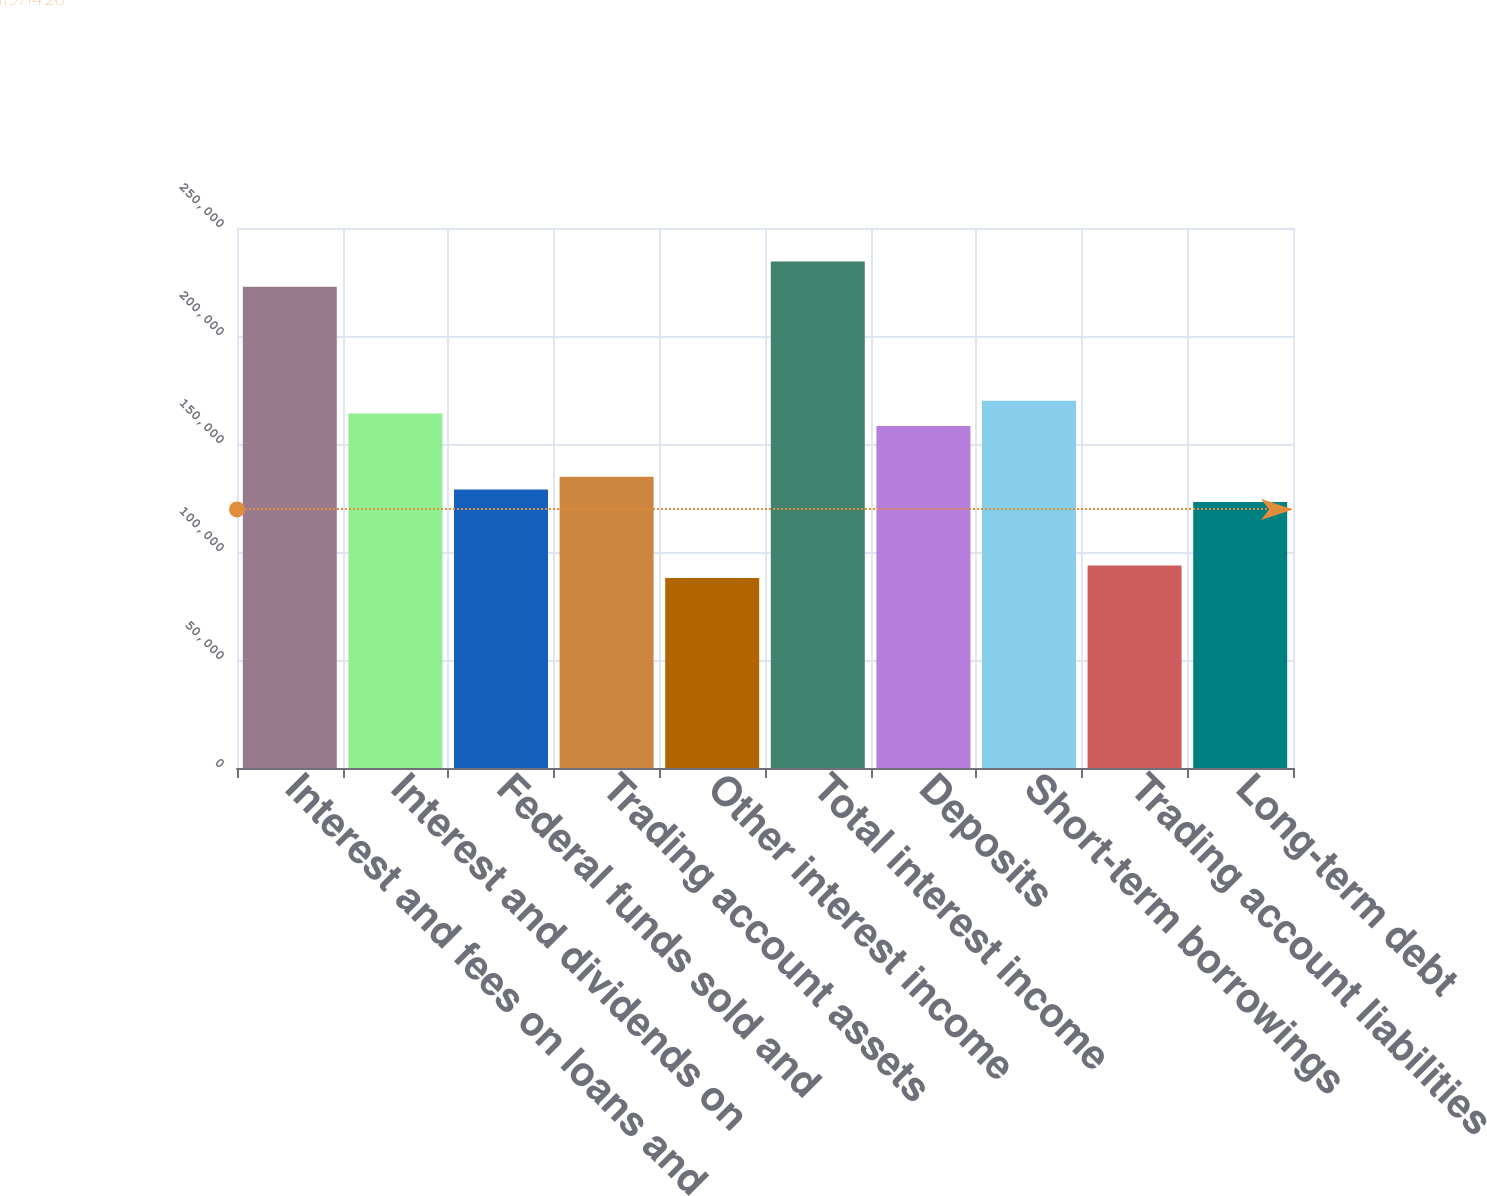Convert chart to OTSL. <chart><loc_0><loc_0><loc_500><loc_500><bar_chart><fcel>Interest and fees on loans and<fcel>Interest and dividends on<fcel>Federal funds sold and<fcel>Trading account assets<fcel>Other interest income<fcel>Total interest income<fcel>Deposits<fcel>Short-term borrowings<fcel>Trading account liabilities<fcel>Long-term debt<nl><fcel>222773<fcel>164149<fcel>128975<fcel>134837<fcel>87938.1<fcel>234498<fcel>158287<fcel>170012<fcel>93800.5<fcel>123113<nl></chart> 